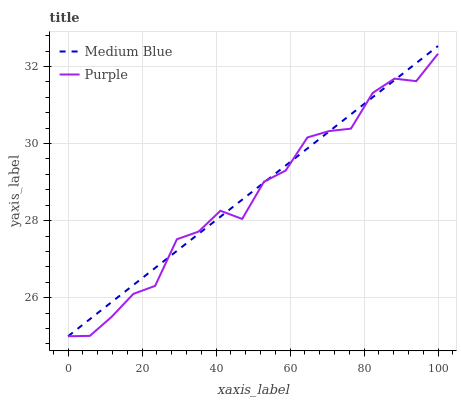Does Medium Blue have the minimum area under the curve?
Answer yes or no. No. Is Medium Blue the roughest?
Answer yes or no. No. 